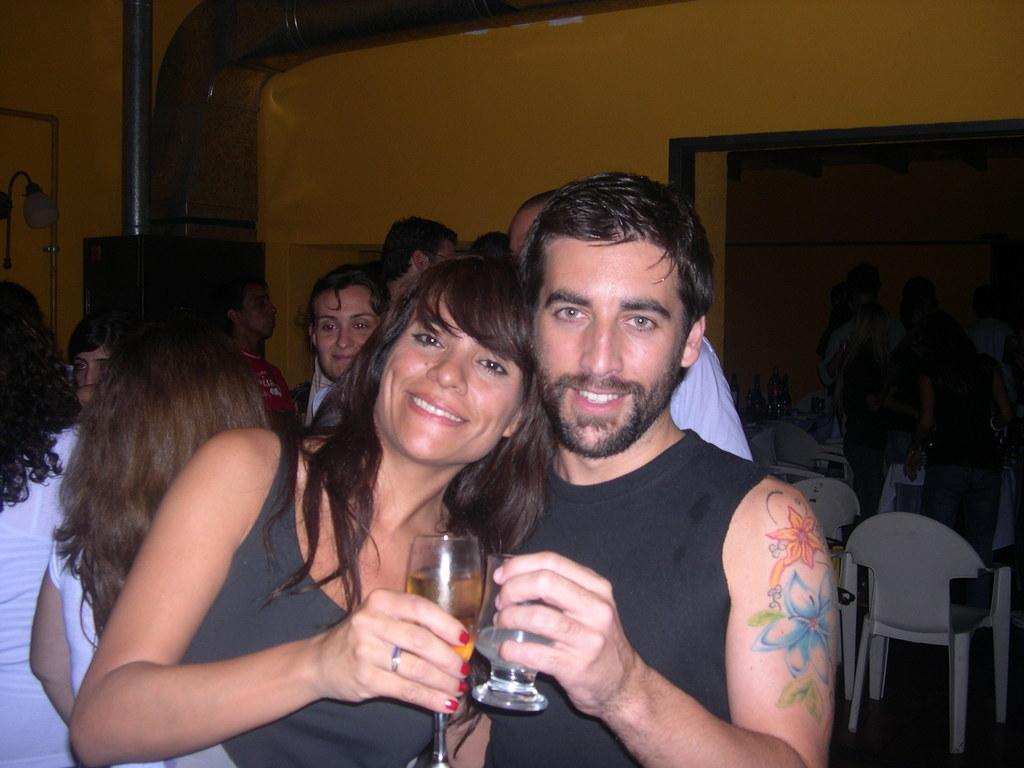How many people are in the image? There are people standing in the image. What are two of the people holding in their hands? Two people are holding wine glasses in their hands. What is the limit of friends allowed in the image? There is no limit on the number of friends in the image, as it only shows people standing. 